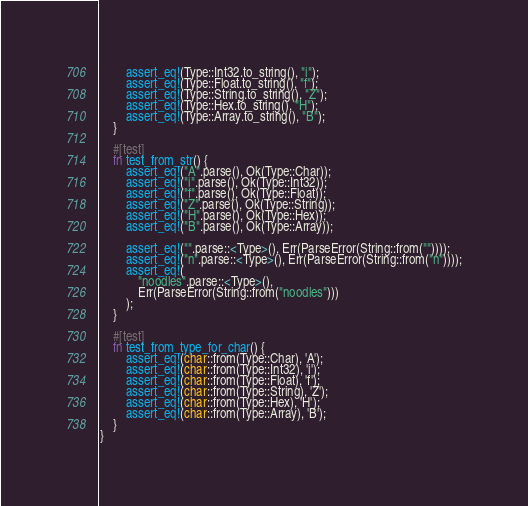Convert code to text. <code><loc_0><loc_0><loc_500><loc_500><_Rust_>        assert_eq!(Type::Int32.to_string(), "i");
        assert_eq!(Type::Float.to_string(), "f");
        assert_eq!(Type::String.to_string(), "Z");
        assert_eq!(Type::Hex.to_string(), "H");
        assert_eq!(Type::Array.to_string(), "B");
    }

    #[test]
    fn test_from_str() {
        assert_eq!("A".parse(), Ok(Type::Char));
        assert_eq!("i".parse(), Ok(Type::Int32));
        assert_eq!("f".parse(), Ok(Type::Float));
        assert_eq!("Z".parse(), Ok(Type::String));
        assert_eq!("H".parse(), Ok(Type::Hex));
        assert_eq!("B".parse(), Ok(Type::Array));

        assert_eq!("".parse::<Type>(), Err(ParseError(String::from(""))));
        assert_eq!("n".parse::<Type>(), Err(ParseError(String::from("n"))));
        assert_eq!(
            "noodles".parse::<Type>(),
            Err(ParseError(String::from("noodles")))
        );
    }

    #[test]
    fn test_from_type_for_char() {
        assert_eq!(char::from(Type::Char), 'A');
        assert_eq!(char::from(Type::Int32), 'i');
        assert_eq!(char::from(Type::Float), 'f');
        assert_eq!(char::from(Type::String), 'Z');
        assert_eq!(char::from(Type::Hex), 'H');
        assert_eq!(char::from(Type::Array), 'B');
    }
}
</code> 